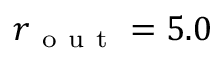Convert formula to latex. <formula><loc_0><loc_0><loc_500><loc_500>r _ { o u t } = 5 . 0</formula> 